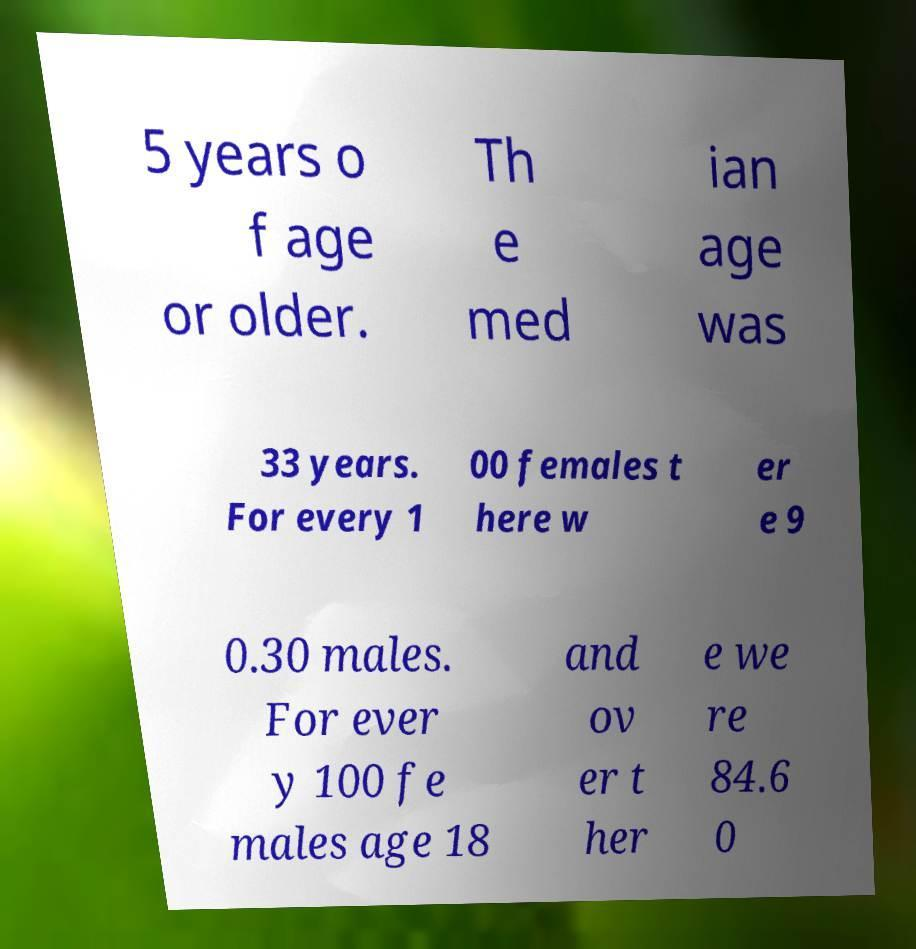For documentation purposes, I need the text within this image transcribed. Could you provide that? 5 years o f age or older. Th e med ian age was 33 years. For every 1 00 females t here w er e 9 0.30 males. For ever y 100 fe males age 18 and ov er t her e we re 84.6 0 